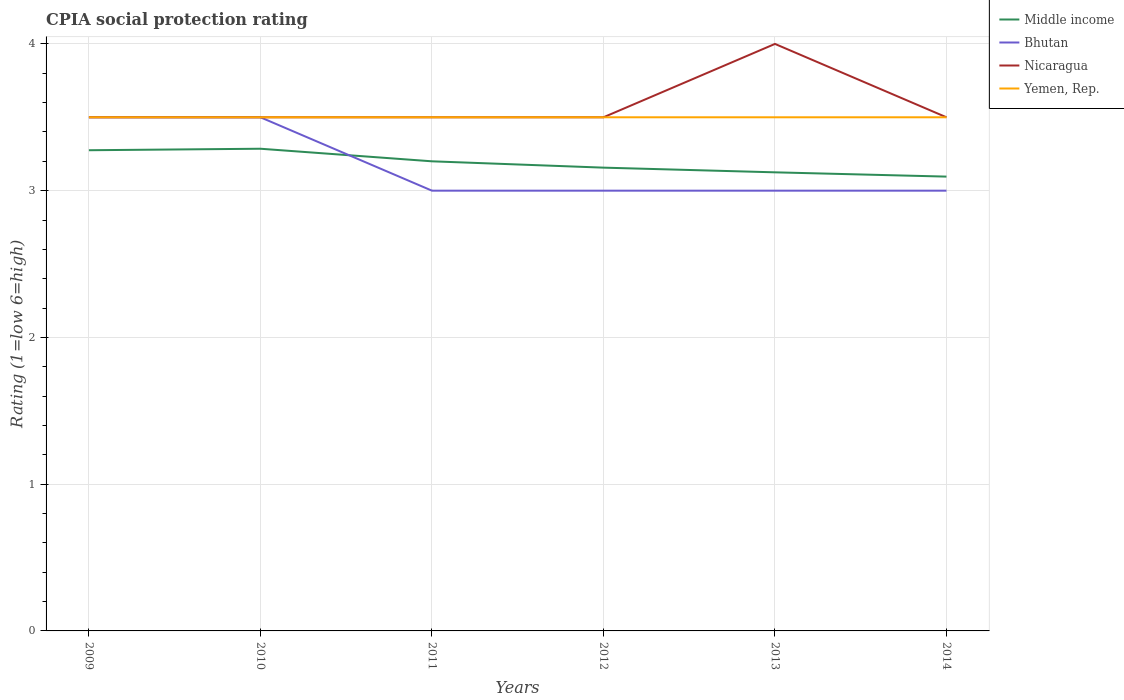Across all years, what is the maximum CPIA rating in Nicaragua?
Ensure brevity in your answer.  3.5. In which year was the CPIA rating in Nicaragua maximum?
Your answer should be very brief. 2009. What is the difference between the highest and the second highest CPIA rating in Middle income?
Provide a succinct answer. 0.19. How many lines are there?
Ensure brevity in your answer.  4. How many years are there in the graph?
Ensure brevity in your answer.  6. What is the difference between two consecutive major ticks on the Y-axis?
Provide a short and direct response. 1. Does the graph contain any zero values?
Offer a terse response. No. Where does the legend appear in the graph?
Offer a terse response. Top right. How many legend labels are there?
Your answer should be very brief. 4. How are the legend labels stacked?
Keep it short and to the point. Vertical. What is the title of the graph?
Offer a very short reply. CPIA social protection rating. What is the label or title of the X-axis?
Your answer should be very brief. Years. What is the label or title of the Y-axis?
Keep it short and to the point. Rating (1=low 6=high). What is the Rating (1=low 6=high) of Middle income in 2009?
Ensure brevity in your answer.  3.28. What is the Rating (1=low 6=high) of Bhutan in 2009?
Keep it short and to the point. 3.5. What is the Rating (1=low 6=high) in Yemen, Rep. in 2009?
Offer a terse response. 3.5. What is the Rating (1=low 6=high) of Middle income in 2010?
Your response must be concise. 3.29. What is the Rating (1=low 6=high) of Bhutan in 2010?
Provide a succinct answer. 3.5. What is the Rating (1=low 6=high) in Yemen, Rep. in 2010?
Make the answer very short. 3.5. What is the Rating (1=low 6=high) of Bhutan in 2011?
Provide a succinct answer. 3. What is the Rating (1=low 6=high) of Nicaragua in 2011?
Ensure brevity in your answer.  3.5. What is the Rating (1=low 6=high) of Middle income in 2012?
Your response must be concise. 3.16. What is the Rating (1=low 6=high) of Bhutan in 2012?
Offer a terse response. 3. What is the Rating (1=low 6=high) in Yemen, Rep. in 2012?
Give a very brief answer. 3.5. What is the Rating (1=low 6=high) in Middle income in 2013?
Offer a very short reply. 3.12. What is the Rating (1=low 6=high) in Bhutan in 2013?
Ensure brevity in your answer.  3. What is the Rating (1=low 6=high) of Yemen, Rep. in 2013?
Make the answer very short. 3.5. What is the Rating (1=low 6=high) in Middle income in 2014?
Your answer should be very brief. 3.1. What is the Rating (1=low 6=high) in Yemen, Rep. in 2014?
Provide a short and direct response. 3.5. Across all years, what is the maximum Rating (1=low 6=high) in Middle income?
Give a very brief answer. 3.29. Across all years, what is the maximum Rating (1=low 6=high) in Nicaragua?
Your answer should be compact. 4. Across all years, what is the minimum Rating (1=low 6=high) of Middle income?
Provide a short and direct response. 3.1. Across all years, what is the minimum Rating (1=low 6=high) in Nicaragua?
Keep it short and to the point. 3.5. Across all years, what is the minimum Rating (1=low 6=high) in Yemen, Rep.?
Give a very brief answer. 3.5. What is the total Rating (1=low 6=high) of Middle income in the graph?
Ensure brevity in your answer.  19.14. What is the total Rating (1=low 6=high) of Yemen, Rep. in the graph?
Offer a terse response. 21. What is the difference between the Rating (1=low 6=high) of Middle income in 2009 and that in 2010?
Provide a short and direct response. -0.01. What is the difference between the Rating (1=low 6=high) of Nicaragua in 2009 and that in 2010?
Your answer should be very brief. 0. What is the difference between the Rating (1=low 6=high) of Middle income in 2009 and that in 2011?
Offer a terse response. 0.08. What is the difference between the Rating (1=low 6=high) in Nicaragua in 2009 and that in 2011?
Provide a short and direct response. 0. What is the difference between the Rating (1=low 6=high) of Middle income in 2009 and that in 2012?
Your response must be concise. 0.12. What is the difference between the Rating (1=low 6=high) in Nicaragua in 2009 and that in 2012?
Your response must be concise. 0. What is the difference between the Rating (1=low 6=high) of Middle income in 2009 and that in 2013?
Make the answer very short. 0.15. What is the difference between the Rating (1=low 6=high) in Nicaragua in 2009 and that in 2013?
Your answer should be very brief. -0.5. What is the difference between the Rating (1=low 6=high) in Middle income in 2009 and that in 2014?
Offer a terse response. 0.18. What is the difference between the Rating (1=low 6=high) in Bhutan in 2009 and that in 2014?
Provide a succinct answer. 0.5. What is the difference between the Rating (1=low 6=high) in Yemen, Rep. in 2009 and that in 2014?
Provide a short and direct response. 0. What is the difference between the Rating (1=low 6=high) in Middle income in 2010 and that in 2011?
Your response must be concise. 0.09. What is the difference between the Rating (1=low 6=high) of Nicaragua in 2010 and that in 2011?
Your answer should be compact. 0. What is the difference between the Rating (1=low 6=high) of Yemen, Rep. in 2010 and that in 2011?
Offer a very short reply. 0. What is the difference between the Rating (1=low 6=high) of Middle income in 2010 and that in 2012?
Offer a very short reply. 0.13. What is the difference between the Rating (1=low 6=high) in Nicaragua in 2010 and that in 2012?
Give a very brief answer. 0. What is the difference between the Rating (1=low 6=high) of Yemen, Rep. in 2010 and that in 2012?
Your response must be concise. 0. What is the difference between the Rating (1=low 6=high) in Middle income in 2010 and that in 2013?
Provide a succinct answer. 0.16. What is the difference between the Rating (1=low 6=high) in Yemen, Rep. in 2010 and that in 2013?
Offer a terse response. 0. What is the difference between the Rating (1=low 6=high) in Middle income in 2010 and that in 2014?
Your answer should be very brief. 0.19. What is the difference between the Rating (1=low 6=high) in Middle income in 2011 and that in 2012?
Ensure brevity in your answer.  0.04. What is the difference between the Rating (1=low 6=high) in Nicaragua in 2011 and that in 2012?
Make the answer very short. 0. What is the difference between the Rating (1=low 6=high) in Middle income in 2011 and that in 2013?
Make the answer very short. 0.07. What is the difference between the Rating (1=low 6=high) of Nicaragua in 2011 and that in 2013?
Offer a very short reply. -0.5. What is the difference between the Rating (1=low 6=high) of Middle income in 2011 and that in 2014?
Make the answer very short. 0.1. What is the difference between the Rating (1=low 6=high) of Yemen, Rep. in 2011 and that in 2014?
Your answer should be compact. 0. What is the difference between the Rating (1=low 6=high) in Middle income in 2012 and that in 2013?
Give a very brief answer. 0.03. What is the difference between the Rating (1=low 6=high) in Bhutan in 2012 and that in 2013?
Ensure brevity in your answer.  0. What is the difference between the Rating (1=low 6=high) in Yemen, Rep. in 2012 and that in 2013?
Give a very brief answer. 0. What is the difference between the Rating (1=low 6=high) in Middle income in 2012 and that in 2014?
Ensure brevity in your answer.  0.06. What is the difference between the Rating (1=low 6=high) of Bhutan in 2012 and that in 2014?
Provide a succinct answer. 0. What is the difference between the Rating (1=low 6=high) of Nicaragua in 2012 and that in 2014?
Your answer should be very brief. 0. What is the difference between the Rating (1=low 6=high) in Yemen, Rep. in 2012 and that in 2014?
Offer a terse response. 0. What is the difference between the Rating (1=low 6=high) in Middle income in 2013 and that in 2014?
Your response must be concise. 0.03. What is the difference between the Rating (1=low 6=high) in Bhutan in 2013 and that in 2014?
Your response must be concise. 0. What is the difference between the Rating (1=low 6=high) in Middle income in 2009 and the Rating (1=low 6=high) in Bhutan in 2010?
Ensure brevity in your answer.  -0.22. What is the difference between the Rating (1=low 6=high) of Middle income in 2009 and the Rating (1=low 6=high) of Nicaragua in 2010?
Provide a succinct answer. -0.22. What is the difference between the Rating (1=low 6=high) of Middle income in 2009 and the Rating (1=low 6=high) of Yemen, Rep. in 2010?
Your response must be concise. -0.22. What is the difference between the Rating (1=low 6=high) of Nicaragua in 2009 and the Rating (1=low 6=high) of Yemen, Rep. in 2010?
Your answer should be compact. 0. What is the difference between the Rating (1=low 6=high) of Middle income in 2009 and the Rating (1=low 6=high) of Bhutan in 2011?
Make the answer very short. 0.28. What is the difference between the Rating (1=low 6=high) of Middle income in 2009 and the Rating (1=low 6=high) of Nicaragua in 2011?
Your answer should be compact. -0.22. What is the difference between the Rating (1=low 6=high) in Middle income in 2009 and the Rating (1=low 6=high) in Yemen, Rep. in 2011?
Make the answer very short. -0.22. What is the difference between the Rating (1=low 6=high) of Bhutan in 2009 and the Rating (1=low 6=high) of Nicaragua in 2011?
Your response must be concise. 0. What is the difference between the Rating (1=low 6=high) of Nicaragua in 2009 and the Rating (1=low 6=high) of Yemen, Rep. in 2011?
Provide a short and direct response. 0. What is the difference between the Rating (1=low 6=high) in Middle income in 2009 and the Rating (1=low 6=high) in Bhutan in 2012?
Provide a short and direct response. 0.28. What is the difference between the Rating (1=low 6=high) in Middle income in 2009 and the Rating (1=low 6=high) in Nicaragua in 2012?
Your response must be concise. -0.22. What is the difference between the Rating (1=low 6=high) in Middle income in 2009 and the Rating (1=low 6=high) in Yemen, Rep. in 2012?
Your answer should be very brief. -0.22. What is the difference between the Rating (1=low 6=high) in Bhutan in 2009 and the Rating (1=low 6=high) in Nicaragua in 2012?
Your answer should be compact. 0. What is the difference between the Rating (1=low 6=high) in Bhutan in 2009 and the Rating (1=low 6=high) in Yemen, Rep. in 2012?
Offer a terse response. 0. What is the difference between the Rating (1=low 6=high) of Nicaragua in 2009 and the Rating (1=low 6=high) of Yemen, Rep. in 2012?
Your response must be concise. 0. What is the difference between the Rating (1=low 6=high) in Middle income in 2009 and the Rating (1=low 6=high) in Bhutan in 2013?
Your answer should be very brief. 0.28. What is the difference between the Rating (1=low 6=high) in Middle income in 2009 and the Rating (1=low 6=high) in Nicaragua in 2013?
Provide a short and direct response. -0.72. What is the difference between the Rating (1=low 6=high) of Middle income in 2009 and the Rating (1=low 6=high) of Yemen, Rep. in 2013?
Your answer should be very brief. -0.22. What is the difference between the Rating (1=low 6=high) of Nicaragua in 2009 and the Rating (1=low 6=high) of Yemen, Rep. in 2013?
Keep it short and to the point. 0. What is the difference between the Rating (1=low 6=high) in Middle income in 2009 and the Rating (1=low 6=high) in Bhutan in 2014?
Your answer should be compact. 0.28. What is the difference between the Rating (1=low 6=high) of Middle income in 2009 and the Rating (1=low 6=high) of Nicaragua in 2014?
Your answer should be compact. -0.22. What is the difference between the Rating (1=low 6=high) of Middle income in 2009 and the Rating (1=low 6=high) of Yemen, Rep. in 2014?
Provide a short and direct response. -0.22. What is the difference between the Rating (1=low 6=high) in Nicaragua in 2009 and the Rating (1=low 6=high) in Yemen, Rep. in 2014?
Your answer should be compact. 0. What is the difference between the Rating (1=low 6=high) in Middle income in 2010 and the Rating (1=low 6=high) in Bhutan in 2011?
Offer a very short reply. 0.29. What is the difference between the Rating (1=low 6=high) of Middle income in 2010 and the Rating (1=low 6=high) of Nicaragua in 2011?
Keep it short and to the point. -0.21. What is the difference between the Rating (1=low 6=high) of Middle income in 2010 and the Rating (1=low 6=high) of Yemen, Rep. in 2011?
Offer a terse response. -0.21. What is the difference between the Rating (1=low 6=high) of Middle income in 2010 and the Rating (1=low 6=high) of Bhutan in 2012?
Your answer should be very brief. 0.29. What is the difference between the Rating (1=low 6=high) of Middle income in 2010 and the Rating (1=low 6=high) of Nicaragua in 2012?
Your answer should be compact. -0.21. What is the difference between the Rating (1=low 6=high) of Middle income in 2010 and the Rating (1=low 6=high) of Yemen, Rep. in 2012?
Ensure brevity in your answer.  -0.21. What is the difference between the Rating (1=low 6=high) in Bhutan in 2010 and the Rating (1=low 6=high) in Nicaragua in 2012?
Give a very brief answer. 0. What is the difference between the Rating (1=low 6=high) in Middle income in 2010 and the Rating (1=low 6=high) in Bhutan in 2013?
Make the answer very short. 0.29. What is the difference between the Rating (1=low 6=high) in Middle income in 2010 and the Rating (1=low 6=high) in Nicaragua in 2013?
Give a very brief answer. -0.71. What is the difference between the Rating (1=low 6=high) of Middle income in 2010 and the Rating (1=low 6=high) of Yemen, Rep. in 2013?
Make the answer very short. -0.21. What is the difference between the Rating (1=low 6=high) in Bhutan in 2010 and the Rating (1=low 6=high) in Yemen, Rep. in 2013?
Provide a succinct answer. 0. What is the difference between the Rating (1=low 6=high) of Nicaragua in 2010 and the Rating (1=low 6=high) of Yemen, Rep. in 2013?
Make the answer very short. 0. What is the difference between the Rating (1=low 6=high) of Middle income in 2010 and the Rating (1=low 6=high) of Bhutan in 2014?
Provide a short and direct response. 0.29. What is the difference between the Rating (1=low 6=high) of Middle income in 2010 and the Rating (1=low 6=high) of Nicaragua in 2014?
Offer a very short reply. -0.21. What is the difference between the Rating (1=low 6=high) in Middle income in 2010 and the Rating (1=low 6=high) in Yemen, Rep. in 2014?
Provide a succinct answer. -0.21. What is the difference between the Rating (1=low 6=high) of Bhutan in 2010 and the Rating (1=low 6=high) of Nicaragua in 2014?
Offer a terse response. 0. What is the difference between the Rating (1=low 6=high) of Nicaragua in 2010 and the Rating (1=low 6=high) of Yemen, Rep. in 2014?
Offer a very short reply. 0. What is the difference between the Rating (1=low 6=high) in Middle income in 2011 and the Rating (1=low 6=high) in Bhutan in 2012?
Your response must be concise. 0.2. What is the difference between the Rating (1=low 6=high) in Middle income in 2011 and the Rating (1=low 6=high) in Yemen, Rep. in 2012?
Give a very brief answer. -0.3. What is the difference between the Rating (1=low 6=high) of Bhutan in 2011 and the Rating (1=low 6=high) of Yemen, Rep. in 2012?
Offer a terse response. -0.5. What is the difference between the Rating (1=low 6=high) in Middle income in 2011 and the Rating (1=low 6=high) in Bhutan in 2013?
Give a very brief answer. 0.2. What is the difference between the Rating (1=low 6=high) of Middle income in 2011 and the Rating (1=low 6=high) of Nicaragua in 2013?
Your answer should be compact. -0.8. What is the difference between the Rating (1=low 6=high) of Middle income in 2011 and the Rating (1=low 6=high) of Yemen, Rep. in 2013?
Provide a succinct answer. -0.3. What is the difference between the Rating (1=low 6=high) of Bhutan in 2011 and the Rating (1=low 6=high) of Yemen, Rep. in 2013?
Make the answer very short. -0.5. What is the difference between the Rating (1=low 6=high) of Nicaragua in 2011 and the Rating (1=low 6=high) of Yemen, Rep. in 2013?
Your answer should be compact. 0. What is the difference between the Rating (1=low 6=high) in Middle income in 2011 and the Rating (1=low 6=high) in Nicaragua in 2014?
Your answer should be very brief. -0.3. What is the difference between the Rating (1=low 6=high) in Middle income in 2011 and the Rating (1=low 6=high) in Yemen, Rep. in 2014?
Your answer should be very brief. -0.3. What is the difference between the Rating (1=low 6=high) of Bhutan in 2011 and the Rating (1=low 6=high) of Nicaragua in 2014?
Give a very brief answer. -0.5. What is the difference between the Rating (1=low 6=high) in Nicaragua in 2011 and the Rating (1=low 6=high) in Yemen, Rep. in 2014?
Ensure brevity in your answer.  0. What is the difference between the Rating (1=low 6=high) of Middle income in 2012 and the Rating (1=low 6=high) of Bhutan in 2013?
Make the answer very short. 0.16. What is the difference between the Rating (1=low 6=high) of Middle income in 2012 and the Rating (1=low 6=high) of Nicaragua in 2013?
Make the answer very short. -0.84. What is the difference between the Rating (1=low 6=high) of Middle income in 2012 and the Rating (1=low 6=high) of Yemen, Rep. in 2013?
Provide a succinct answer. -0.34. What is the difference between the Rating (1=low 6=high) in Bhutan in 2012 and the Rating (1=low 6=high) in Yemen, Rep. in 2013?
Give a very brief answer. -0.5. What is the difference between the Rating (1=low 6=high) in Nicaragua in 2012 and the Rating (1=low 6=high) in Yemen, Rep. in 2013?
Your response must be concise. 0. What is the difference between the Rating (1=low 6=high) of Middle income in 2012 and the Rating (1=low 6=high) of Bhutan in 2014?
Offer a terse response. 0.16. What is the difference between the Rating (1=low 6=high) of Middle income in 2012 and the Rating (1=low 6=high) of Nicaragua in 2014?
Your answer should be compact. -0.34. What is the difference between the Rating (1=low 6=high) of Middle income in 2012 and the Rating (1=low 6=high) of Yemen, Rep. in 2014?
Provide a succinct answer. -0.34. What is the difference between the Rating (1=low 6=high) of Bhutan in 2012 and the Rating (1=low 6=high) of Yemen, Rep. in 2014?
Offer a terse response. -0.5. What is the difference between the Rating (1=low 6=high) in Nicaragua in 2012 and the Rating (1=low 6=high) in Yemen, Rep. in 2014?
Offer a very short reply. 0. What is the difference between the Rating (1=low 6=high) in Middle income in 2013 and the Rating (1=low 6=high) in Bhutan in 2014?
Your answer should be compact. 0.12. What is the difference between the Rating (1=low 6=high) of Middle income in 2013 and the Rating (1=low 6=high) of Nicaragua in 2014?
Your response must be concise. -0.38. What is the difference between the Rating (1=low 6=high) of Middle income in 2013 and the Rating (1=low 6=high) of Yemen, Rep. in 2014?
Offer a terse response. -0.38. What is the difference between the Rating (1=low 6=high) of Bhutan in 2013 and the Rating (1=low 6=high) of Nicaragua in 2014?
Your answer should be compact. -0.5. What is the difference between the Rating (1=low 6=high) in Nicaragua in 2013 and the Rating (1=low 6=high) in Yemen, Rep. in 2014?
Your response must be concise. 0.5. What is the average Rating (1=low 6=high) of Middle income per year?
Ensure brevity in your answer.  3.19. What is the average Rating (1=low 6=high) of Bhutan per year?
Offer a very short reply. 3.17. What is the average Rating (1=low 6=high) of Nicaragua per year?
Provide a succinct answer. 3.58. What is the average Rating (1=low 6=high) in Yemen, Rep. per year?
Your answer should be very brief. 3.5. In the year 2009, what is the difference between the Rating (1=low 6=high) of Middle income and Rating (1=low 6=high) of Bhutan?
Offer a very short reply. -0.22. In the year 2009, what is the difference between the Rating (1=low 6=high) in Middle income and Rating (1=low 6=high) in Nicaragua?
Your answer should be compact. -0.22. In the year 2009, what is the difference between the Rating (1=low 6=high) in Middle income and Rating (1=low 6=high) in Yemen, Rep.?
Offer a very short reply. -0.22. In the year 2009, what is the difference between the Rating (1=low 6=high) in Nicaragua and Rating (1=low 6=high) in Yemen, Rep.?
Your answer should be compact. 0. In the year 2010, what is the difference between the Rating (1=low 6=high) of Middle income and Rating (1=low 6=high) of Bhutan?
Offer a very short reply. -0.21. In the year 2010, what is the difference between the Rating (1=low 6=high) of Middle income and Rating (1=low 6=high) of Nicaragua?
Give a very brief answer. -0.21. In the year 2010, what is the difference between the Rating (1=low 6=high) in Middle income and Rating (1=low 6=high) in Yemen, Rep.?
Your answer should be very brief. -0.21. In the year 2010, what is the difference between the Rating (1=low 6=high) of Bhutan and Rating (1=low 6=high) of Nicaragua?
Your response must be concise. 0. In the year 2011, what is the difference between the Rating (1=low 6=high) in Middle income and Rating (1=low 6=high) in Bhutan?
Offer a very short reply. 0.2. In the year 2011, what is the difference between the Rating (1=low 6=high) in Middle income and Rating (1=low 6=high) in Nicaragua?
Give a very brief answer. -0.3. In the year 2011, what is the difference between the Rating (1=low 6=high) of Middle income and Rating (1=low 6=high) of Yemen, Rep.?
Offer a very short reply. -0.3. In the year 2011, what is the difference between the Rating (1=low 6=high) of Bhutan and Rating (1=low 6=high) of Nicaragua?
Your answer should be compact. -0.5. In the year 2012, what is the difference between the Rating (1=low 6=high) of Middle income and Rating (1=low 6=high) of Bhutan?
Your response must be concise. 0.16. In the year 2012, what is the difference between the Rating (1=low 6=high) in Middle income and Rating (1=low 6=high) in Nicaragua?
Keep it short and to the point. -0.34. In the year 2012, what is the difference between the Rating (1=low 6=high) in Middle income and Rating (1=low 6=high) in Yemen, Rep.?
Your answer should be very brief. -0.34. In the year 2012, what is the difference between the Rating (1=low 6=high) of Bhutan and Rating (1=low 6=high) of Yemen, Rep.?
Ensure brevity in your answer.  -0.5. In the year 2012, what is the difference between the Rating (1=low 6=high) in Nicaragua and Rating (1=low 6=high) in Yemen, Rep.?
Give a very brief answer. 0. In the year 2013, what is the difference between the Rating (1=low 6=high) of Middle income and Rating (1=low 6=high) of Bhutan?
Your answer should be compact. 0.12. In the year 2013, what is the difference between the Rating (1=low 6=high) of Middle income and Rating (1=low 6=high) of Nicaragua?
Keep it short and to the point. -0.88. In the year 2013, what is the difference between the Rating (1=low 6=high) of Middle income and Rating (1=low 6=high) of Yemen, Rep.?
Ensure brevity in your answer.  -0.38. In the year 2013, what is the difference between the Rating (1=low 6=high) of Bhutan and Rating (1=low 6=high) of Nicaragua?
Make the answer very short. -1. In the year 2013, what is the difference between the Rating (1=low 6=high) of Nicaragua and Rating (1=low 6=high) of Yemen, Rep.?
Offer a very short reply. 0.5. In the year 2014, what is the difference between the Rating (1=low 6=high) in Middle income and Rating (1=low 6=high) in Bhutan?
Make the answer very short. 0.1. In the year 2014, what is the difference between the Rating (1=low 6=high) of Middle income and Rating (1=low 6=high) of Nicaragua?
Your response must be concise. -0.4. In the year 2014, what is the difference between the Rating (1=low 6=high) in Middle income and Rating (1=low 6=high) in Yemen, Rep.?
Make the answer very short. -0.4. In the year 2014, what is the difference between the Rating (1=low 6=high) in Bhutan and Rating (1=low 6=high) in Yemen, Rep.?
Ensure brevity in your answer.  -0.5. In the year 2014, what is the difference between the Rating (1=low 6=high) of Nicaragua and Rating (1=low 6=high) of Yemen, Rep.?
Provide a succinct answer. 0. What is the ratio of the Rating (1=low 6=high) of Bhutan in 2009 to that in 2010?
Provide a short and direct response. 1. What is the ratio of the Rating (1=low 6=high) of Nicaragua in 2009 to that in 2010?
Keep it short and to the point. 1. What is the ratio of the Rating (1=low 6=high) of Yemen, Rep. in 2009 to that in 2010?
Provide a short and direct response. 1. What is the ratio of the Rating (1=low 6=high) in Middle income in 2009 to that in 2011?
Offer a very short reply. 1.02. What is the ratio of the Rating (1=low 6=high) of Bhutan in 2009 to that in 2011?
Provide a short and direct response. 1.17. What is the ratio of the Rating (1=low 6=high) in Nicaragua in 2009 to that in 2011?
Offer a terse response. 1. What is the ratio of the Rating (1=low 6=high) in Middle income in 2009 to that in 2012?
Provide a short and direct response. 1.04. What is the ratio of the Rating (1=low 6=high) in Bhutan in 2009 to that in 2012?
Your answer should be compact. 1.17. What is the ratio of the Rating (1=low 6=high) in Middle income in 2009 to that in 2013?
Offer a terse response. 1.05. What is the ratio of the Rating (1=low 6=high) of Nicaragua in 2009 to that in 2013?
Make the answer very short. 0.88. What is the ratio of the Rating (1=low 6=high) of Middle income in 2009 to that in 2014?
Your answer should be very brief. 1.06. What is the ratio of the Rating (1=low 6=high) of Bhutan in 2009 to that in 2014?
Your answer should be compact. 1.17. What is the ratio of the Rating (1=low 6=high) of Nicaragua in 2009 to that in 2014?
Ensure brevity in your answer.  1. What is the ratio of the Rating (1=low 6=high) of Yemen, Rep. in 2009 to that in 2014?
Keep it short and to the point. 1. What is the ratio of the Rating (1=low 6=high) of Middle income in 2010 to that in 2011?
Ensure brevity in your answer.  1.03. What is the ratio of the Rating (1=low 6=high) of Bhutan in 2010 to that in 2011?
Offer a terse response. 1.17. What is the ratio of the Rating (1=low 6=high) of Nicaragua in 2010 to that in 2011?
Offer a terse response. 1. What is the ratio of the Rating (1=low 6=high) in Yemen, Rep. in 2010 to that in 2011?
Provide a succinct answer. 1. What is the ratio of the Rating (1=low 6=high) of Middle income in 2010 to that in 2012?
Your answer should be very brief. 1.04. What is the ratio of the Rating (1=low 6=high) in Nicaragua in 2010 to that in 2012?
Ensure brevity in your answer.  1. What is the ratio of the Rating (1=low 6=high) of Yemen, Rep. in 2010 to that in 2012?
Your response must be concise. 1. What is the ratio of the Rating (1=low 6=high) in Middle income in 2010 to that in 2013?
Your answer should be very brief. 1.05. What is the ratio of the Rating (1=low 6=high) in Yemen, Rep. in 2010 to that in 2013?
Ensure brevity in your answer.  1. What is the ratio of the Rating (1=low 6=high) of Middle income in 2010 to that in 2014?
Keep it short and to the point. 1.06. What is the ratio of the Rating (1=low 6=high) of Nicaragua in 2010 to that in 2014?
Give a very brief answer. 1. What is the ratio of the Rating (1=low 6=high) of Middle income in 2011 to that in 2012?
Provide a short and direct response. 1.01. What is the ratio of the Rating (1=low 6=high) in Bhutan in 2011 to that in 2012?
Provide a succinct answer. 1. What is the ratio of the Rating (1=low 6=high) in Nicaragua in 2011 to that in 2013?
Keep it short and to the point. 0.88. What is the ratio of the Rating (1=low 6=high) in Middle income in 2011 to that in 2014?
Your answer should be compact. 1.03. What is the ratio of the Rating (1=low 6=high) in Bhutan in 2011 to that in 2014?
Offer a terse response. 1. What is the ratio of the Rating (1=low 6=high) in Yemen, Rep. in 2011 to that in 2014?
Offer a very short reply. 1. What is the ratio of the Rating (1=low 6=high) in Middle income in 2012 to that in 2013?
Give a very brief answer. 1.01. What is the ratio of the Rating (1=low 6=high) of Middle income in 2012 to that in 2014?
Provide a short and direct response. 1.02. What is the ratio of the Rating (1=low 6=high) in Yemen, Rep. in 2012 to that in 2014?
Ensure brevity in your answer.  1. What is the ratio of the Rating (1=low 6=high) in Middle income in 2013 to that in 2014?
Make the answer very short. 1.01. What is the ratio of the Rating (1=low 6=high) in Bhutan in 2013 to that in 2014?
Ensure brevity in your answer.  1. What is the ratio of the Rating (1=low 6=high) in Nicaragua in 2013 to that in 2014?
Keep it short and to the point. 1.14. What is the ratio of the Rating (1=low 6=high) in Yemen, Rep. in 2013 to that in 2014?
Give a very brief answer. 1. What is the difference between the highest and the second highest Rating (1=low 6=high) of Middle income?
Keep it short and to the point. 0.01. What is the difference between the highest and the second highest Rating (1=low 6=high) in Nicaragua?
Ensure brevity in your answer.  0.5. What is the difference between the highest and the lowest Rating (1=low 6=high) of Middle income?
Your answer should be compact. 0.19. What is the difference between the highest and the lowest Rating (1=low 6=high) in Bhutan?
Provide a short and direct response. 0.5. What is the difference between the highest and the lowest Rating (1=low 6=high) of Yemen, Rep.?
Your response must be concise. 0. 